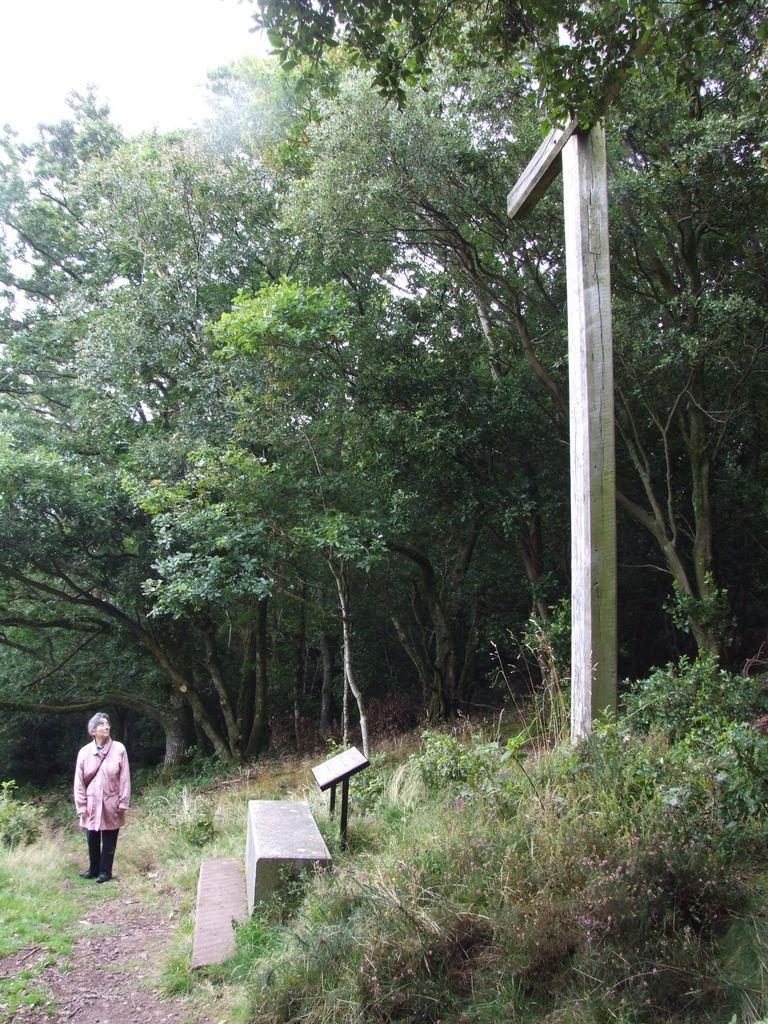What is the primary subject of the image? There is a person standing in the image. What is the person standing on? The person is standing on grass. What other objects or structures are present in the image? There is a bench, plants, a board, and a pole in the image. What can be seen in the background of the image? There are trees and the sky visible in the background of the image. What type of environment might the image have been taken in? The image may have been taken in a forest, given the presence of trees and grass. How many pies are being held by the person in the image? There are no pies visible in the image; the person is not holding any. What shape is the board in the image? The shape of the board cannot be determined from the image, as it is not visible in enough detail. 